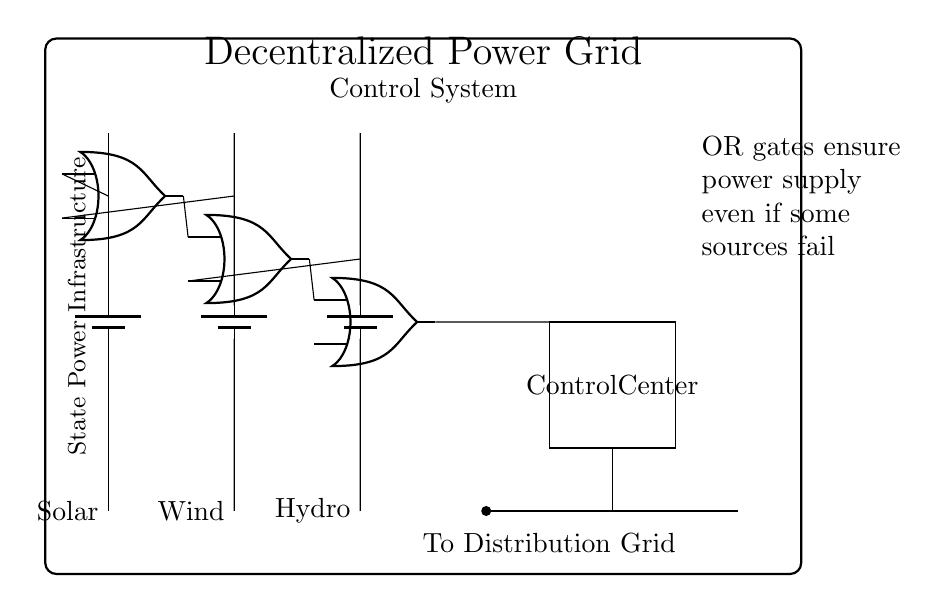What type of power sources are used in this circuit? The circuit shows three power sources, which are Solar, Wind, and Hydro. This can be seen in the labels next to the battery symbols in the diagram.
Answer: Solar, Wind, Hydro How many OR gates are present in the circuit? The diagram contains three OR gates, indicated by the shapes labeled as "or port" in the circuit. Each gate is distinct in the layout.
Answer: Three What is the purpose of the OR gates in this circuit? The OR gates are used to ensure power redundancy, allowing the system to maintain functionality even if one or more power sources fail, as indicated in the note next to the circuit diagram.
Answer: Redundancy What happens if one power source fails? If one power source fails, the remaining sources can still provide power due to the nature of the OR gates, which output power as long as at least one input is active. This is because the OR operation requires only one high input to produce a high output.
Answer: Power remains available What does the control center represent in this circuit? The control center is responsible for managing and regulating the flow of power from the combined outputs of the OR gates to the distribution grid, as shown in the box labeled "Control Center."
Answer: Control Center How does the circuit layout illustrate decentralization? The layout shows multiple independent power sources that feed into a centralized system without dependency on a single source, highlighting the decentralization of power generation. Each source can operate independently, contributing to the overall supply.
Answer: Decentralization 